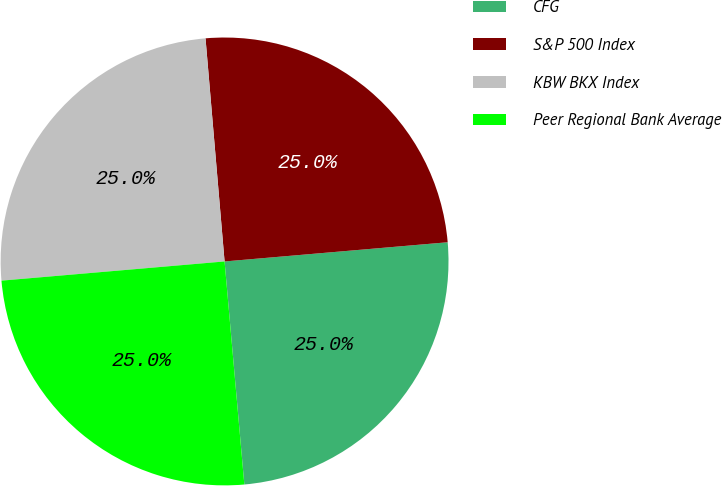<chart> <loc_0><loc_0><loc_500><loc_500><pie_chart><fcel>CFG<fcel>S&P 500 Index<fcel>KBW BKX Index<fcel>Peer Regional Bank Average<nl><fcel>24.96%<fcel>24.99%<fcel>25.01%<fcel>25.04%<nl></chart> 